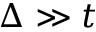<formula> <loc_0><loc_0><loc_500><loc_500>\Delta \gg t</formula> 